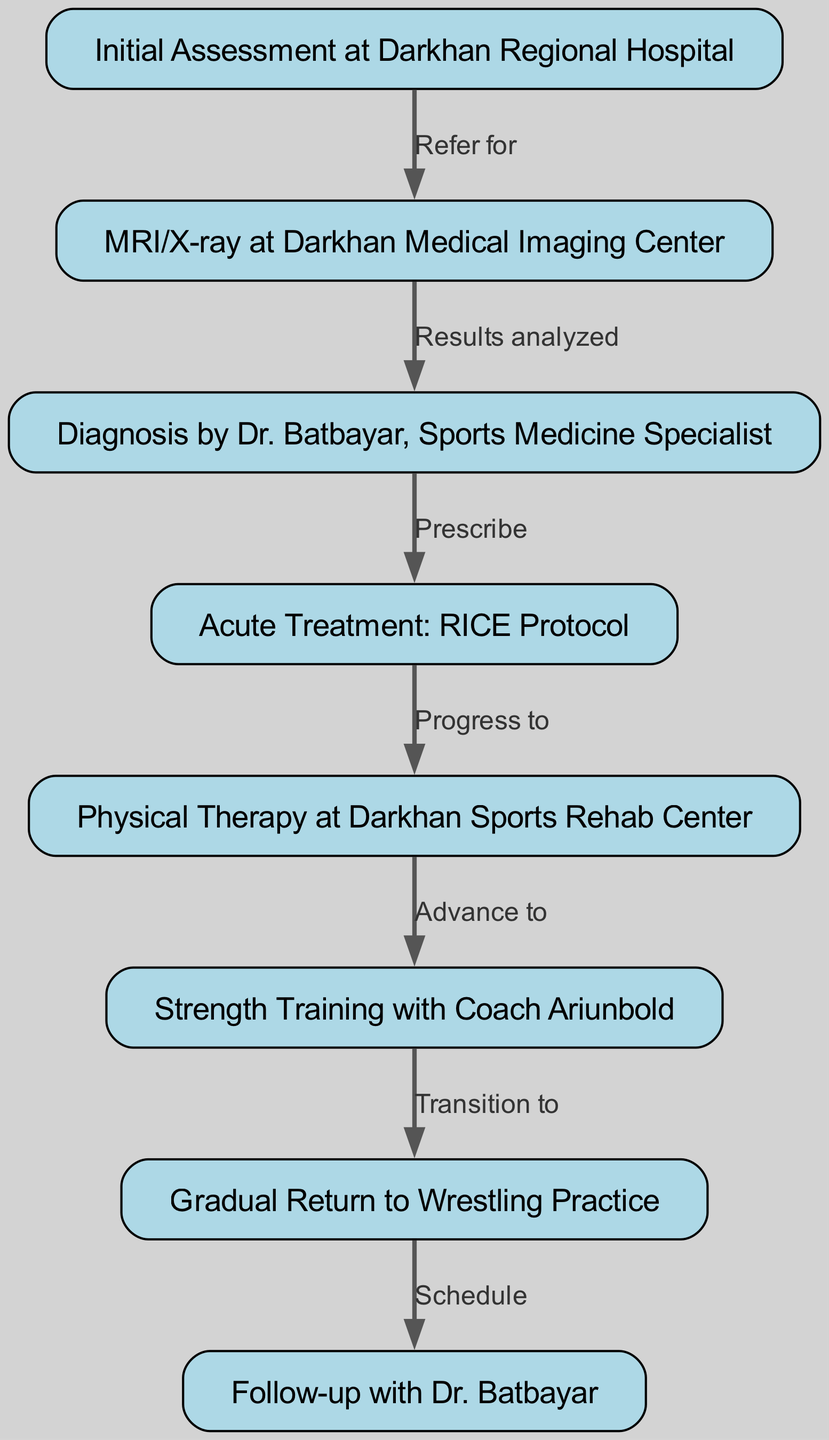What is the first step in the clinical pathway? The first node in the diagram is "Initial Assessment at Darkhan Regional Hospital," which shows that this is the starting point of the clinical pathway.
Answer: Initial Assessment at Darkhan Regional Hospital How many nodes are present in the diagram? By counting the number of nodes listed in the data, we can identify that there are 8 nodes in total representing various steps in the rehabilitation process.
Answer: 8 What is the relationship between "initial assessment" and "imaging"? The edge connecting "initial assessment" and "imaging" is labeled "Refer for," indicating that patients are referred for imaging after the initial assessment.
Answer: Refer for Which treatment follows the acute treatment? After the "Acute Treatment: RICE Protocol," the pathway progresses to "Physical Therapy at Darkhan Sports Rehab Center," making physical therapy the next step.
Answer: Physical Therapy at Darkhan Sports Rehab Center What role does Dr. Batbayar play in the pathway? Dr. Batbayar is identified as the Sports Medicine Specialist who provides a diagnosis after analyzing the results of the imaging, indicating his critical role in the pathway.
Answer: Diagnosis by Dr. Batbayar, Sports Medicine Specialist What is the last step in the clinical pathway? The final node in the diagram is "Follow-up with Dr. Batbayar," which indicates that a follow-up consultation occurs after the gradual return to wrestling practice.
Answer: Follow-up with Dr. Batbayar What phase comes after physical therapy? The pathway moves to "Strength Training with Coach Ariunbold" after the physical therapy phase has been completed, indicating a progression in treatment.
Answer: Strength Training with Coach Ariunbold Which step indicates the start of returning to wrestling? The step labeled "Gradual Return to Wrestling Practice" indicates the phase where the athlete begins to return to their wrestling activities, following strength training.
Answer: Gradual Return to Wrestling Practice How does a patient move from strength training to return to wrestling? The transition from strength training to return to wrestling is illustrated by the edge labeled "Transition to," which describes the flow from one stage to the next.
Answer: Transition to 